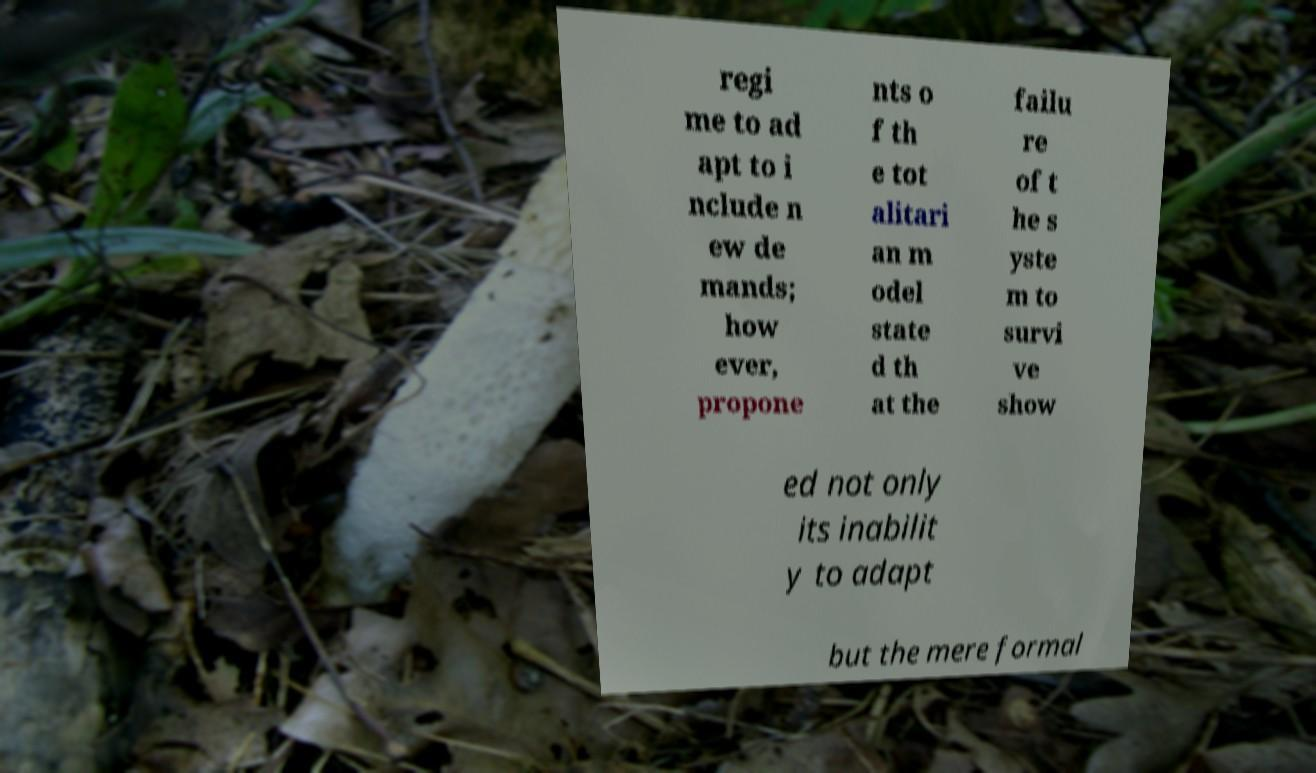For documentation purposes, I need the text within this image transcribed. Could you provide that? regi me to ad apt to i nclude n ew de mands; how ever, propone nts o f th e tot alitari an m odel state d th at the failu re of t he s yste m to survi ve show ed not only its inabilit y to adapt but the mere formal 